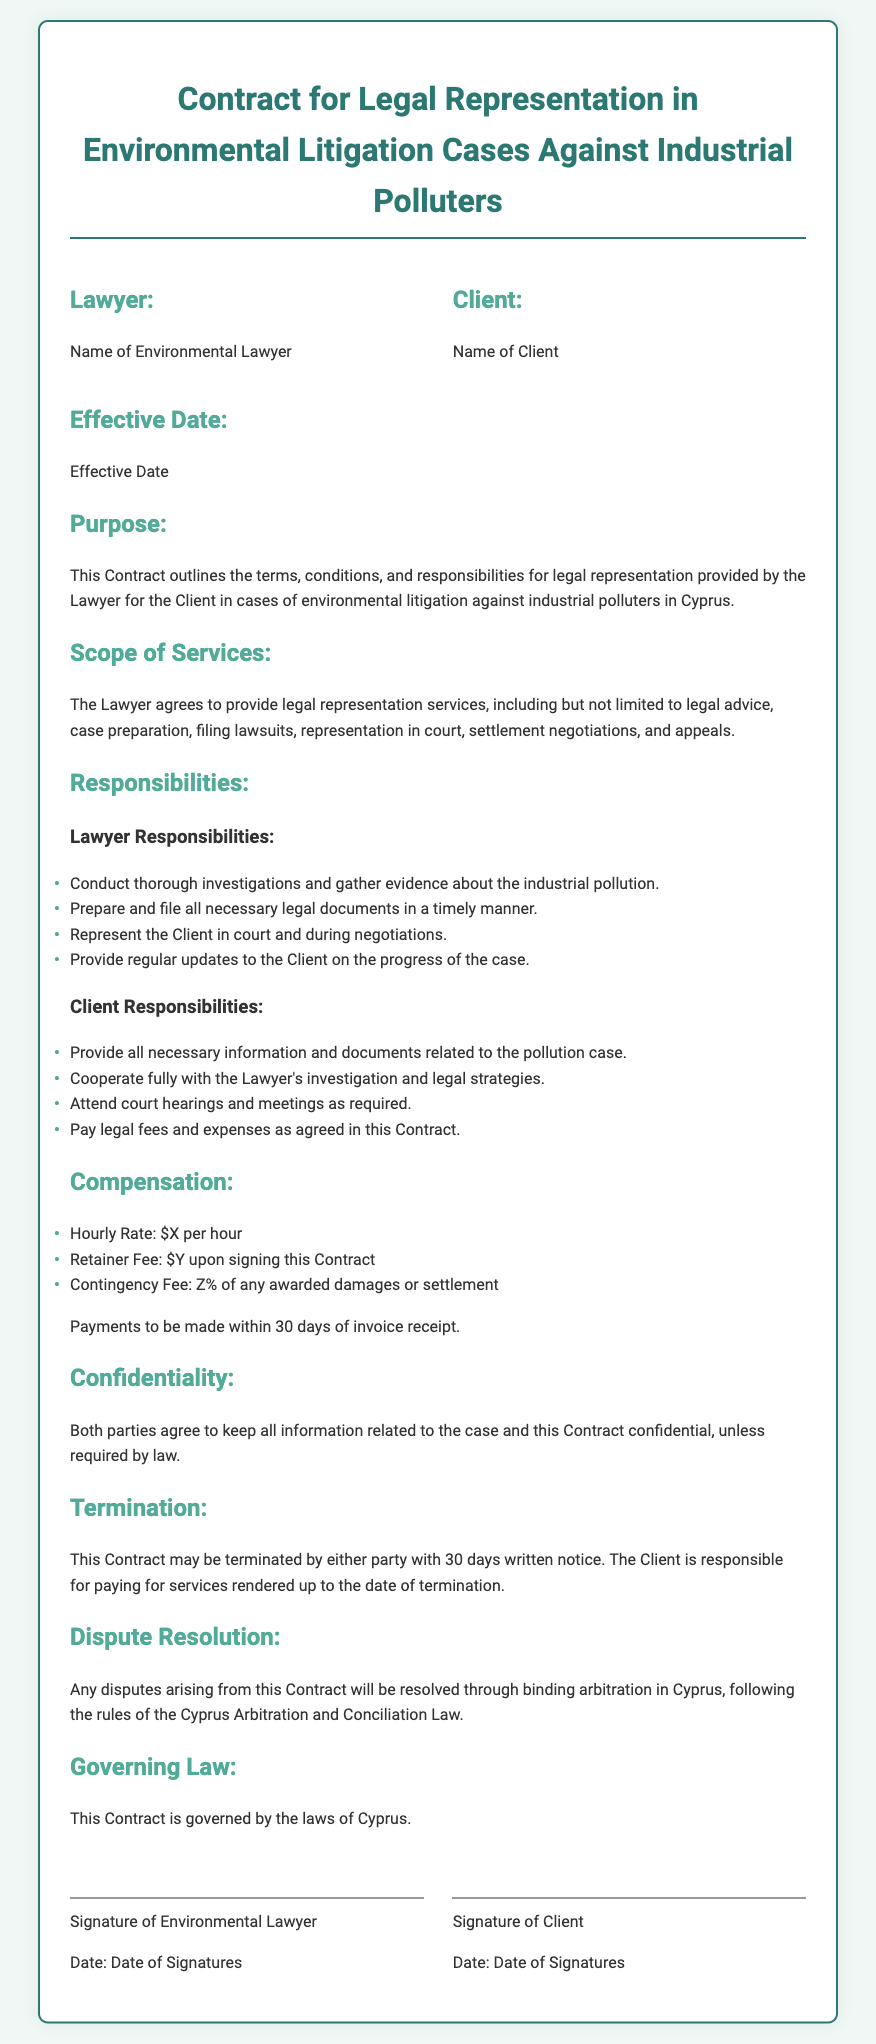what is the name of the lawyer? The name of the lawyer is specified in the Contract under the "Lawyer" section.
Answer: Name of Environmental Lawyer what is the name of the client? The name of the client is specified in the Contract under the "Client" section.
Answer: Name of Client what is the effective date of the contract? The effective date is stated in the Contract under the "Effective Date" section.
Answer: Effective Date what is the retainer fee upon signing? The retainer fee is indicated under the "Compensation" section of the Contract.
Answer: $Y what is the contingency fee percentage? The contingency fee percentage is mentioned in the "Compensation" section of the Contract.
Answer: Z% who prepares and files legal documents? This responsibility is detailed in the "Lawyer Responsibilities" section, where duties are assigned.
Answer: Lawyer what must the client provide for the case? The client's requirement is outlined under "Client Responsibilities" as essential information for the case.
Answer: Necessary information and documents how long is the notice period for termination? The notice period for termination is specified in the "Termination" section of the Contract.
Answer: 30 days how are disputes resolved according to the contract? The dispute resolution process is outlined in the "Dispute Resolution" section of the Contract.
Answer: Binding arbitration what law governs this contract? The governing law is stated in the final section of the Contract.
Answer: Laws of Cyprus 